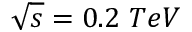Convert formula to latex. <formula><loc_0><loc_0><loc_500><loc_500>\sqrt { s } = 0 . 2 \ T e V</formula> 